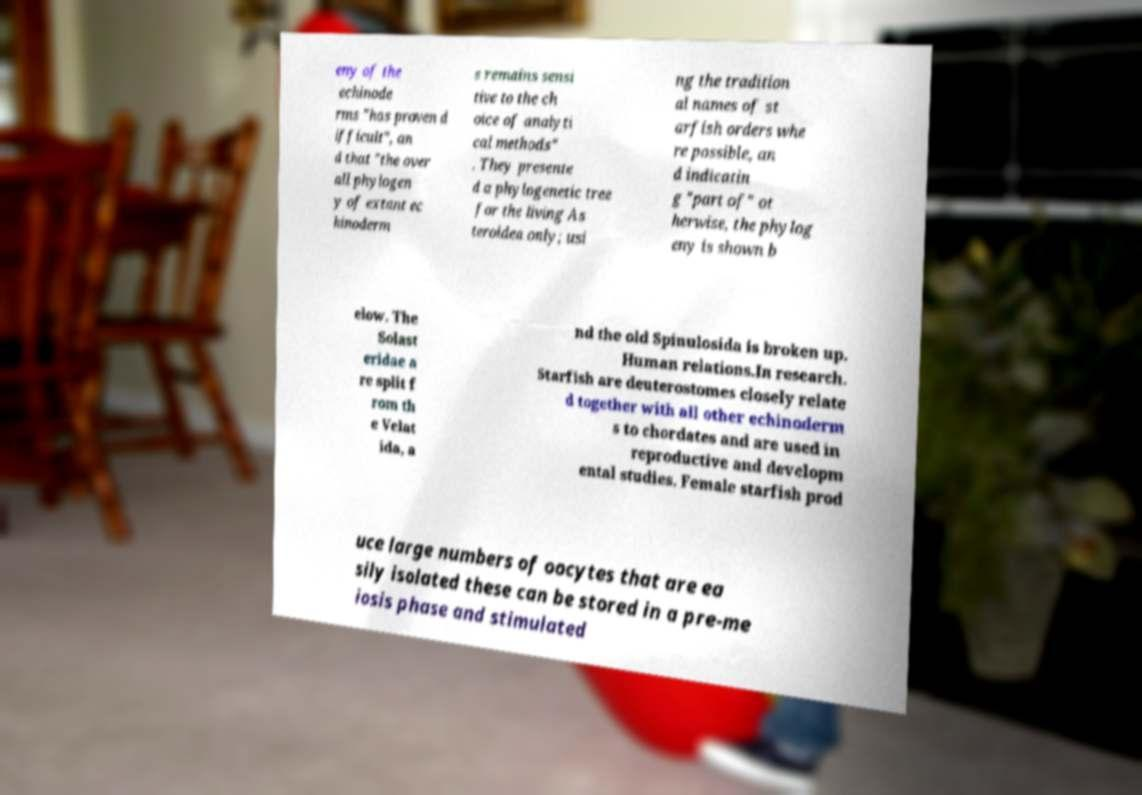Can you accurately transcribe the text from the provided image for me? eny of the echinode rms "has proven d ifficult", an d that "the over all phylogen y of extant ec hinoderm s remains sensi tive to the ch oice of analyti cal methods" . They presente d a phylogenetic tree for the living As teroidea only; usi ng the tradition al names of st arfish orders whe re possible, an d indicatin g "part of" ot herwise, the phylog eny is shown b elow. The Solast eridae a re split f rom th e Velat ida, a nd the old Spinulosida is broken up. Human relations.In research. Starfish are deuterostomes closely relate d together with all other echinoderm s to chordates and are used in reproductive and developm ental studies. Female starfish prod uce large numbers of oocytes that are ea sily isolated these can be stored in a pre-me iosis phase and stimulated 